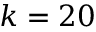Convert formula to latex. <formula><loc_0><loc_0><loc_500><loc_500>k = 2 0</formula> 